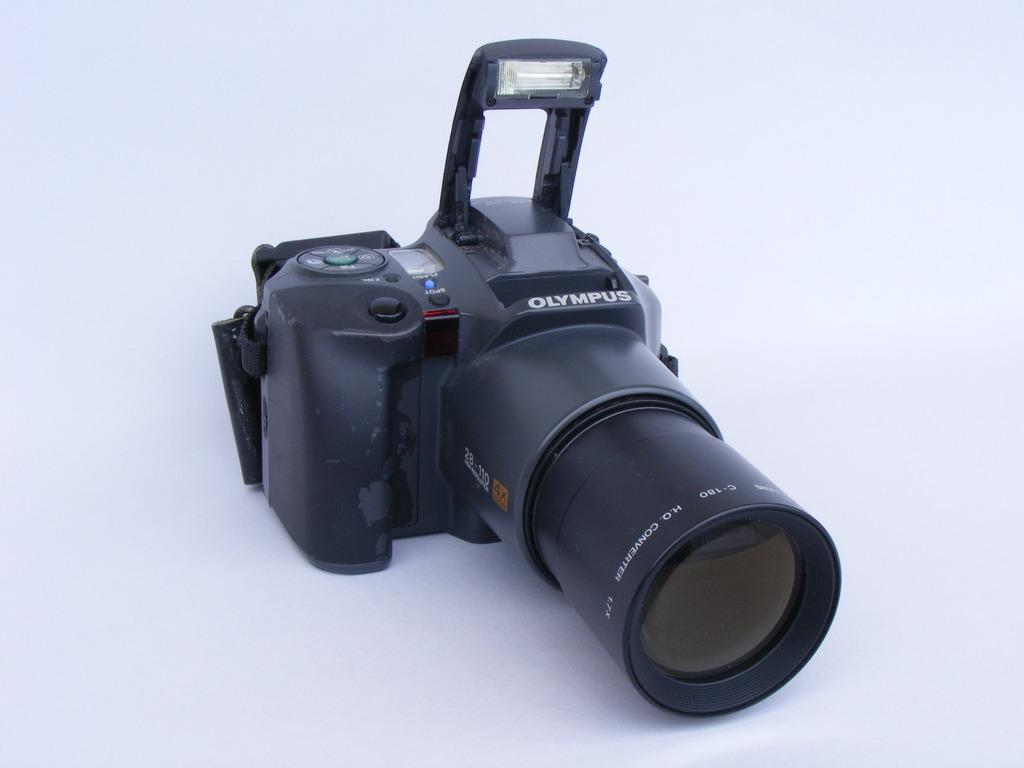What object is the main subject of the image? There is a camera in the image. What color is the camera? The camera is black in color. What can be seen behind the camera in the image? There is a white background in the image. What type of drug is being used in the image? There is no drug present in the image; it features a black camera against a white background. What type of home is shown in the image? There is no home depicted in the image; it only shows a black camera against a white background. 